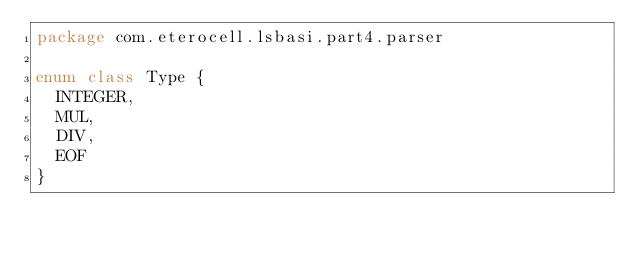Convert code to text. <code><loc_0><loc_0><loc_500><loc_500><_Kotlin_>package com.eterocell.lsbasi.part4.parser

enum class Type {
  INTEGER,
  MUL,
  DIV,
  EOF
}</code> 